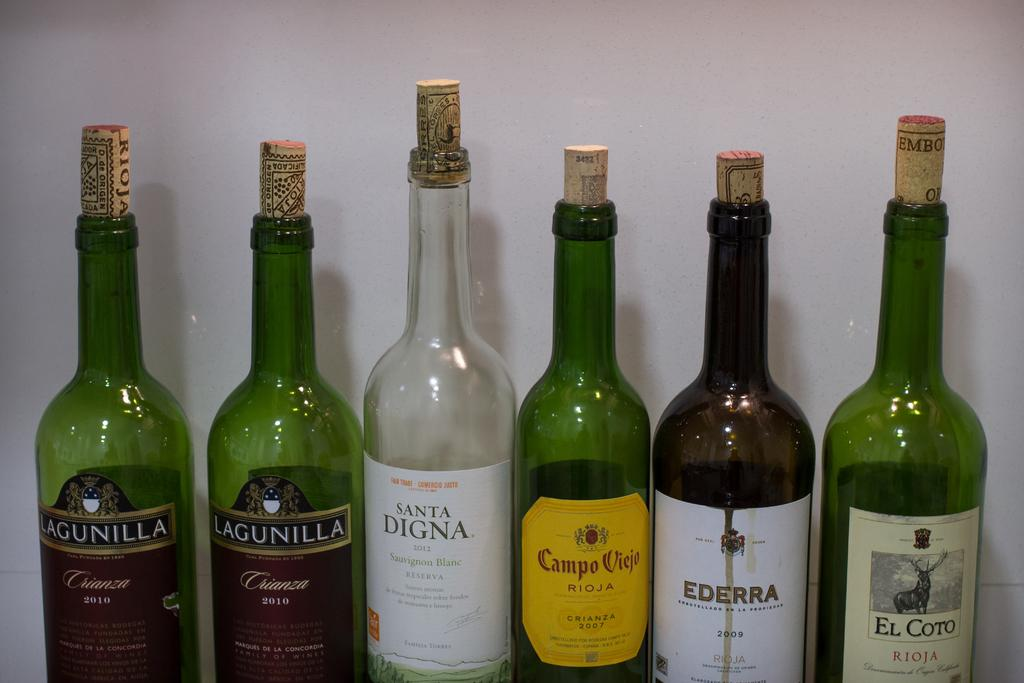<image>
Describe the image concisely. The third bottle from the left is a bottle of 2012 Santa Digna Sauvignon Blanc. 